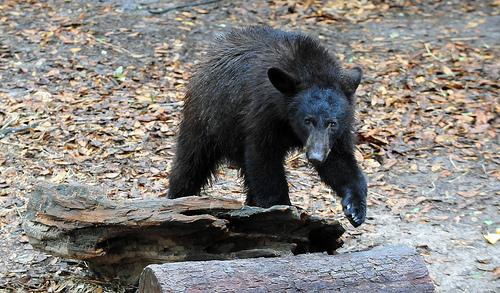Create a caption for the bear's features and the surrounding environment. A young black bear with wide eyes, a distinct nose, and large ears is standing on a rock amidst logs, rocks, and fallen leaves on the ground. Evaluate the complexity of reasoning skills required to understand the image. Moderate complexity reasoning skills are needed to understand the image, as it involves identifying various objects, their positions, and the bear's relation to its environment. Estimate the image quality by mentioning the size of the largest object. The image quality seems to be decent, as the largest object has a width and height of 496. Provide a brief description of the image involving the main object and the environment. A young black bear is standing on a rock surrounded by leaves, a log, and a large rock on the ground. Explain the interaction between the bear and its environment. The black bear is interacting with its environment by standing on a rock and being surrounded by natural objects such as leaves, logs, and rocks. List the objects on the ground and their respective heights. Log (Height: 317), rock (Height: 227), and leaves (Height: 81). Name three parts of the bear's body mentioned in the image and their widths. Three parts are the ear (Width: 35), the paw (Width: 46), and the nose (Width: 39). Classify the emotions the image may bring based on the presence of a black bear. The image may evoke emotions of awe, excitement, and caution due to the presence of a black bear. Identify the largest and smallest objects in terms of width and height. The largest object is a bunch of leaves on a forest floor (Width: 496, Height: 496) and the smallest object is a left black bear ear (Width: 30, Height: 30). 